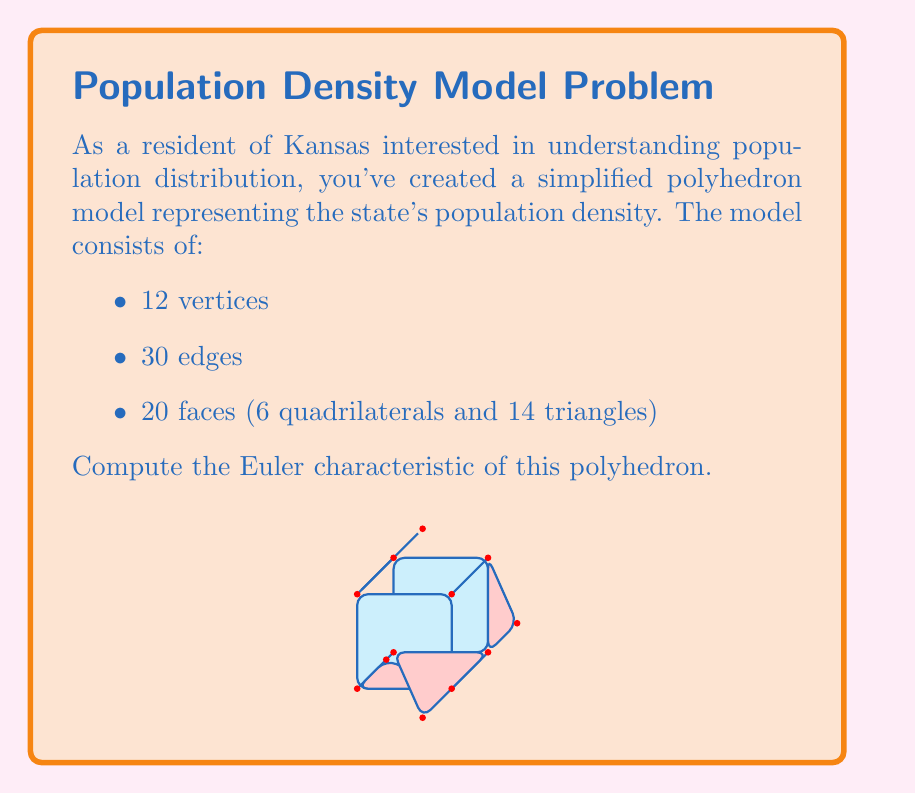Give your solution to this math problem. To compute the Euler characteristic of a polyhedron, we use the formula:

$$\chi = V - E + F$$

Where:
$\chi$ is the Euler characteristic
$V$ is the number of vertices
$E$ is the number of edges
$F$ is the number of faces

Given:
- Number of vertices $(V) = 12$
- Number of edges $(E) = 30$
- Number of faces $(F) = 20$ (6 quadrilaterals and 14 triangles)

Let's substitute these values into the formula:

$$\chi = V - E + F$$
$$\chi = 12 - 30 + 20$$
$$\chi = 2$$

The Euler characteristic of this polyhedron is 2, which is consistent with the fact that it's topologically equivalent to a sphere. This is a common result for simple closed polyhedra without holes.

For a Democrat in Kansas, this model could represent how population density varies across the state, with vertices potentially indicating major cities or population centers, and faces representing rural areas or counties. The Euler characteristic remains constant regardless of how the population distribution changes, as long as the overall topological structure (i.e., a closed surface without holes) is maintained.
Answer: $\chi = 2$ 